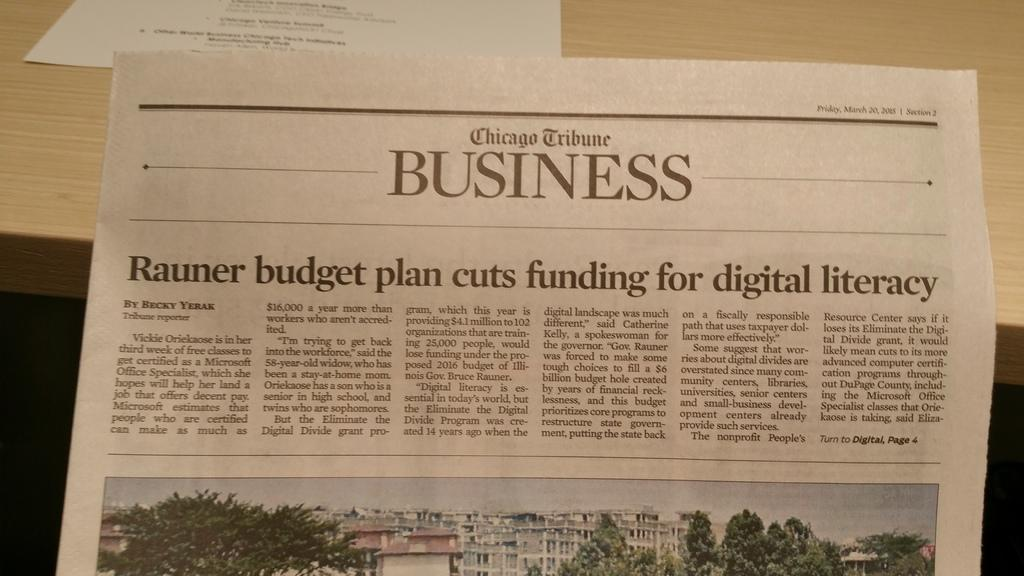<image>
Describe the image concisely. An image of a business page from the Chicago Tribune 